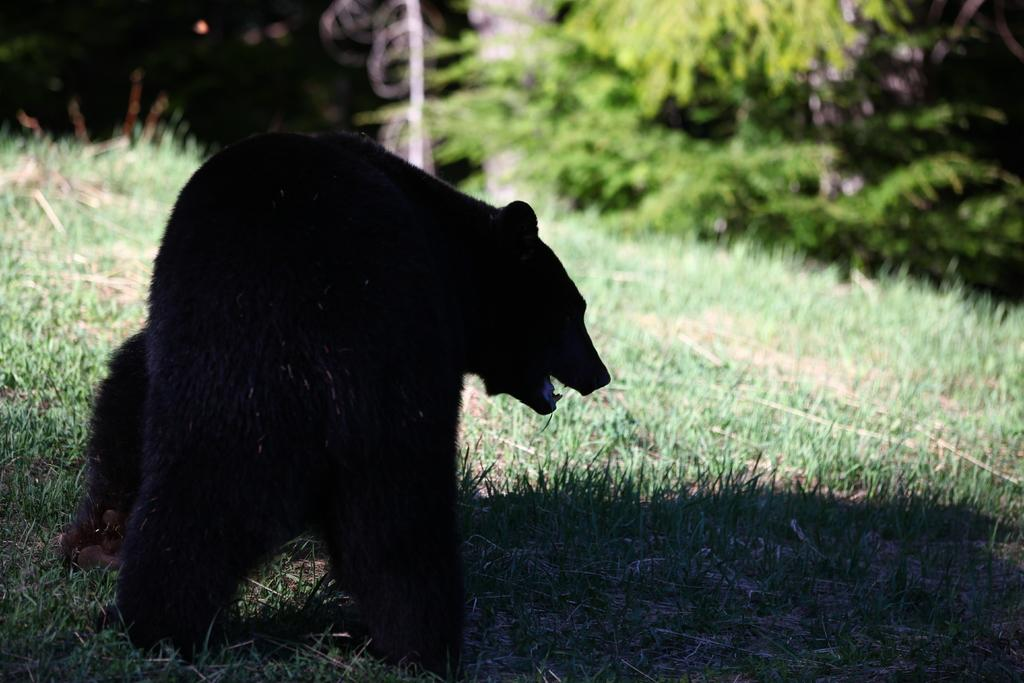What is the main subject in the center of the image? There is an animal in the center of the image. What type of terrain is visible at the bottom of the image? There is grass at the bottom of the image. What can be seen in the background of the image? There are trees in the background of the image. What type of transport is the manager using in the image? There is no transport or manager present in the image. 